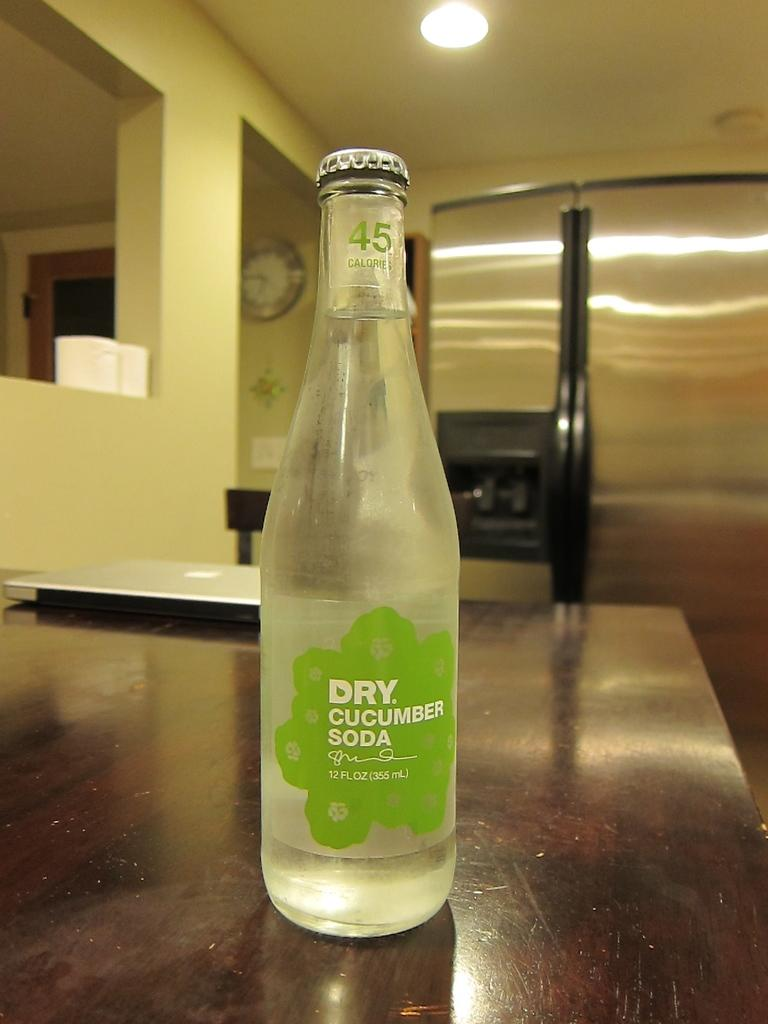<image>
Relay a brief, clear account of the picture shown. a bottle on a counter that is labeled 'dry cucumber soda' in green and white 